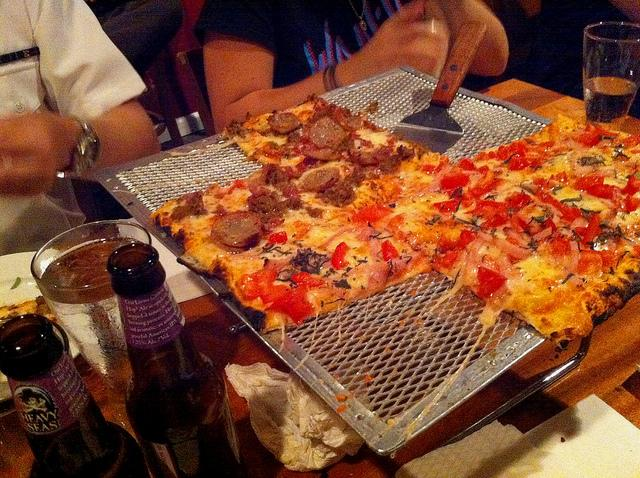What is the topping shown?

Choices:
A) mustard
B) pepperoni
C) sausage
D) bell pepper bell pepper 